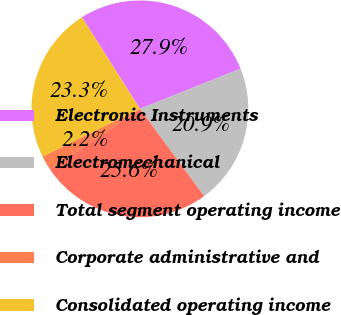Convert chart to OTSL. <chart><loc_0><loc_0><loc_500><loc_500><pie_chart><fcel>Electronic Instruments<fcel>Electromechanical<fcel>Total segment operating income<fcel>Corporate administrative and<fcel>Consolidated operating income<nl><fcel>27.94%<fcel>20.95%<fcel>25.61%<fcel>2.24%<fcel>23.28%<nl></chart> 